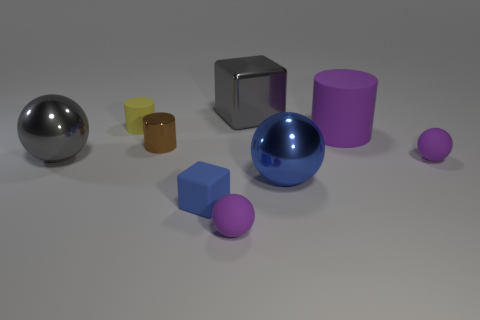Subtract 1 spheres. How many spheres are left? 3 Add 1 tiny brown metal spheres. How many objects exist? 10 Subtract all spheres. How many objects are left? 5 Add 5 large red metal cylinders. How many large red metal cylinders exist? 5 Subtract 1 yellow cylinders. How many objects are left? 8 Subtract all tiny blue objects. Subtract all balls. How many objects are left? 4 Add 7 brown metallic things. How many brown metallic things are left? 8 